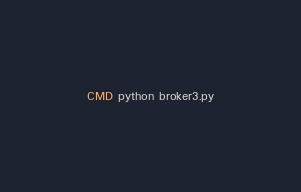Convert code to text. <code><loc_0><loc_0><loc_500><loc_500><_Dockerfile_>CMD python broker3.py


</code> 